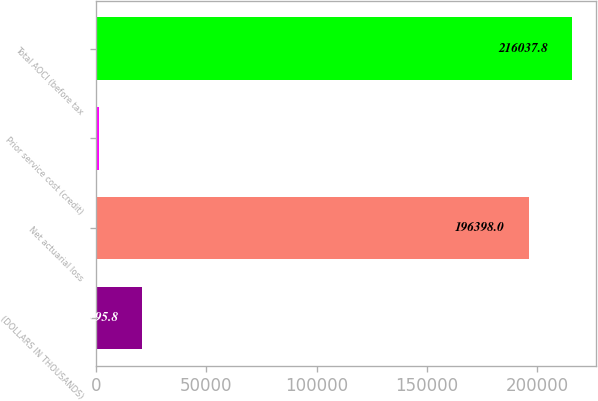Convert chart. <chart><loc_0><loc_0><loc_500><loc_500><bar_chart><fcel>(DOLLARS IN THOUSANDS)<fcel>Net actuarial loss<fcel>Prior service cost (credit)<fcel>Total AOCI (before tax<nl><fcel>20795.8<fcel>196398<fcel>1156<fcel>216038<nl></chart> 